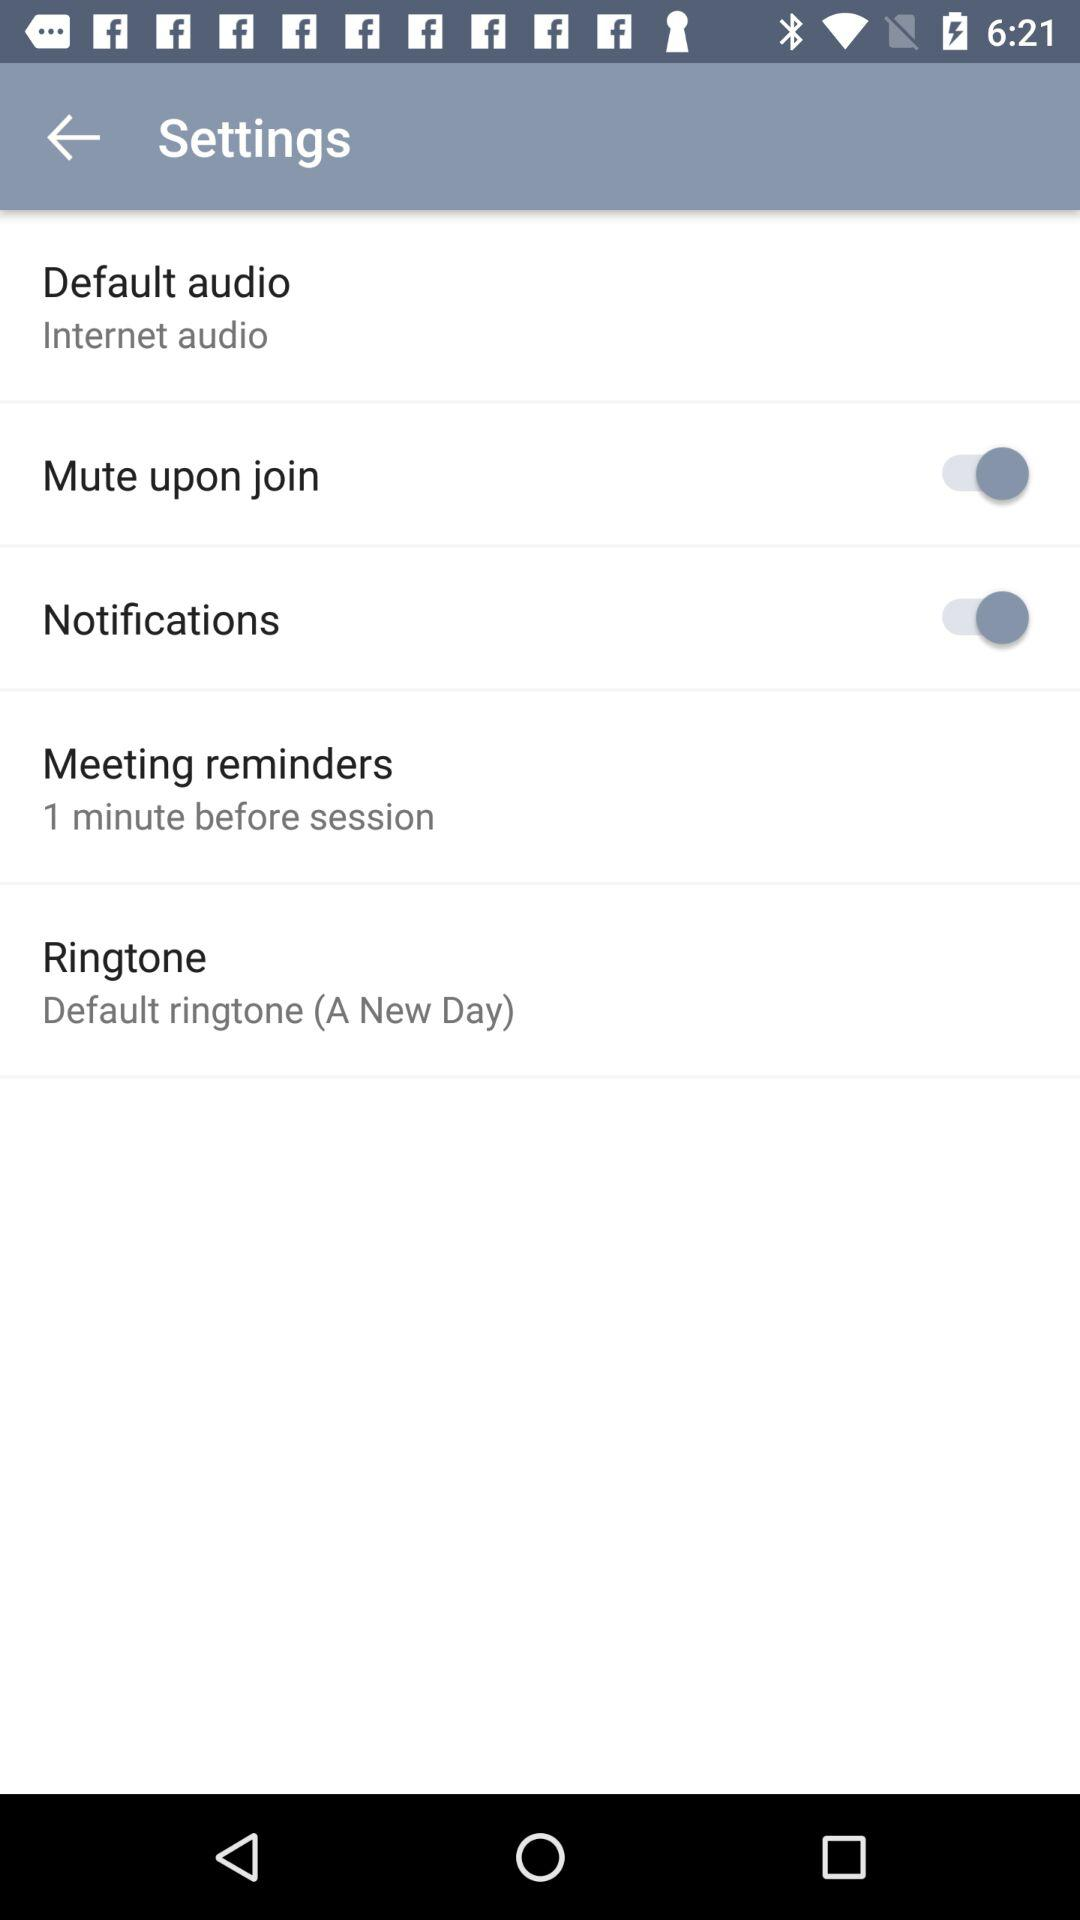How long before the meeting reminder rings? The meeting reminder rings 1 minute before the session. 